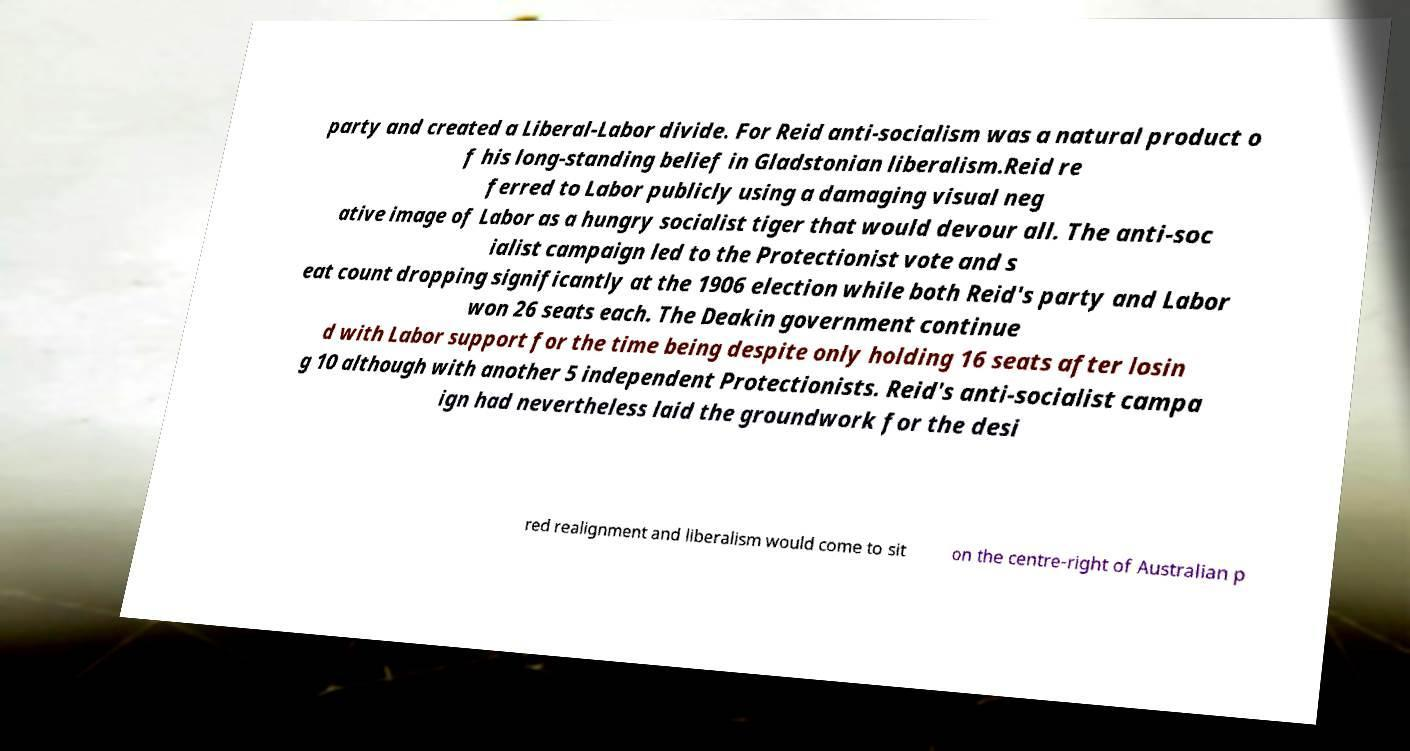I need the written content from this picture converted into text. Can you do that? party and created a Liberal-Labor divide. For Reid anti-socialism was a natural product o f his long-standing belief in Gladstonian liberalism.Reid re ferred to Labor publicly using a damaging visual neg ative image of Labor as a hungry socialist tiger that would devour all. The anti-soc ialist campaign led to the Protectionist vote and s eat count dropping significantly at the 1906 election while both Reid's party and Labor won 26 seats each. The Deakin government continue d with Labor support for the time being despite only holding 16 seats after losin g 10 although with another 5 independent Protectionists. Reid's anti-socialist campa ign had nevertheless laid the groundwork for the desi red realignment and liberalism would come to sit on the centre-right of Australian p 